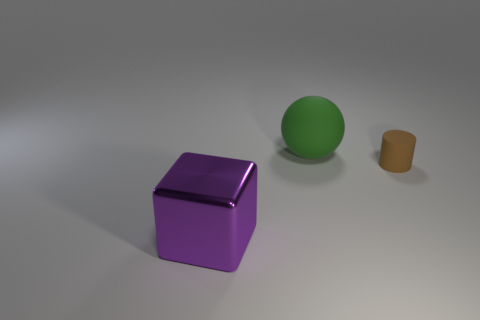Add 3 large purple objects. How many objects exist? 6 Subtract all balls. How many objects are left? 2 Add 3 brown rubber cylinders. How many brown rubber cylinders are left? 4 Add 3 large green balls. How many large green balls exist? 4 Subtract 0 yellow balls. How many objects are left? 3 Subtract all purple spheres. Subtract all small matte cylinders. How many objects are left? 2 